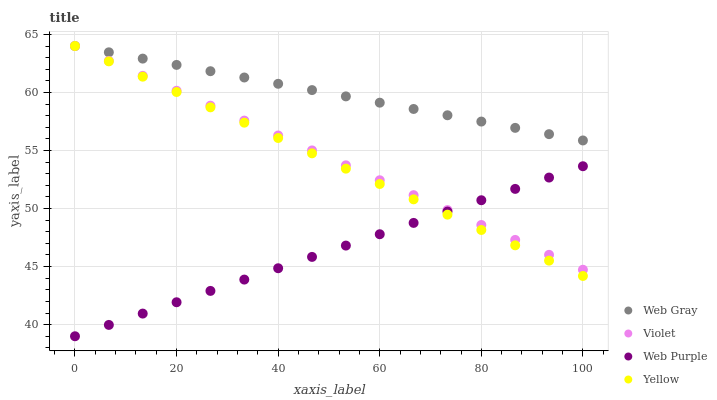Does Web Purple have the minimum area under the curve?
Answer yes or no. Yes. Does Web Gray have the maximum area under the curve?
Answer yes or no. Yes. Does Yellow have the minimum area under the curve?
Answer yes or no. No. Does Yellow have the maximum area under the curve?
Answer yes or no. No. Is Yellow the smoothest?
Answer yes or no. Yes. Is Web Gray the roughest?
Answer yes or no. Yes. Is Web Gray the smoothest?
Answer yes or no. No. Is Yellow the roughest?
Answer yes or no. No. Does Web Purple have the lowest value?
Answer yes or no. Yes. Does Yellow have the lowest value?
Answer yes or no. No. Does Violet have the highest value?
Answer yes or no. Yes. Is Web Purple less than Web Gray?
Answer yes or no. Yes. Is Web Gray greater than Web Purple?
Answer yes or no. Yes. Does Web Purple intersect Yellow?
Answer yes or no. Yes. Is Web Purple less than Yellow?
Answer yes or no. No. Is Web Purple greater than Yellow?
Answer yes or no. No. Does Web Purple intersect Web Gray?
Answer yes or no. No. 